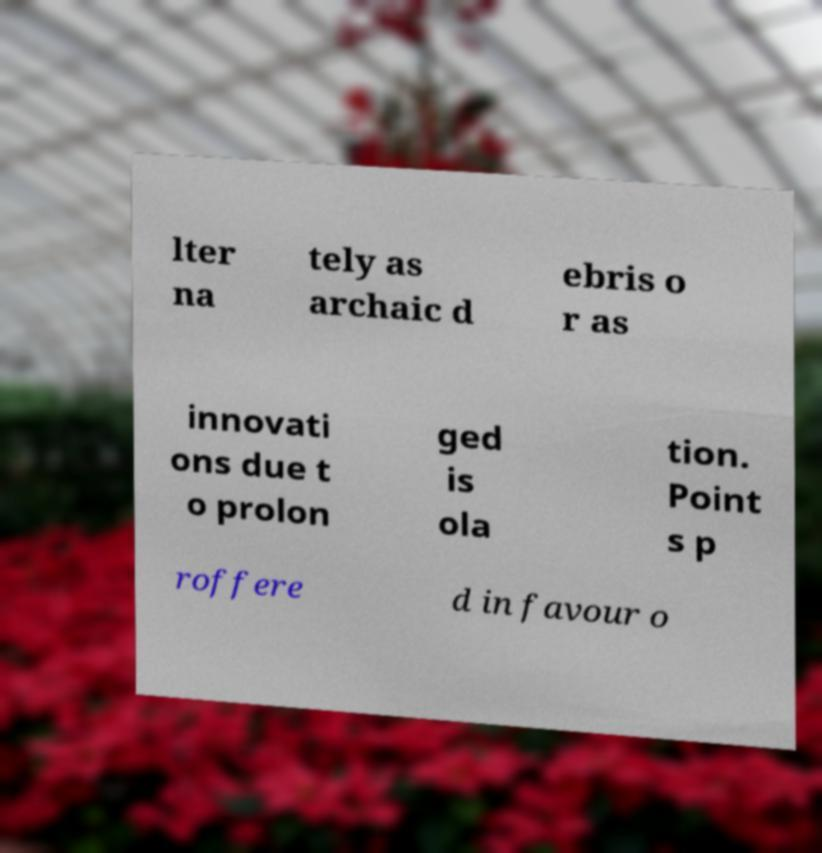I need the written content from this picture converted into text. Can you do that? lter na tely as archaic d ebris o r as innovati ons due t o prolon ged is ola tion. Point s p roffere d in favour o 